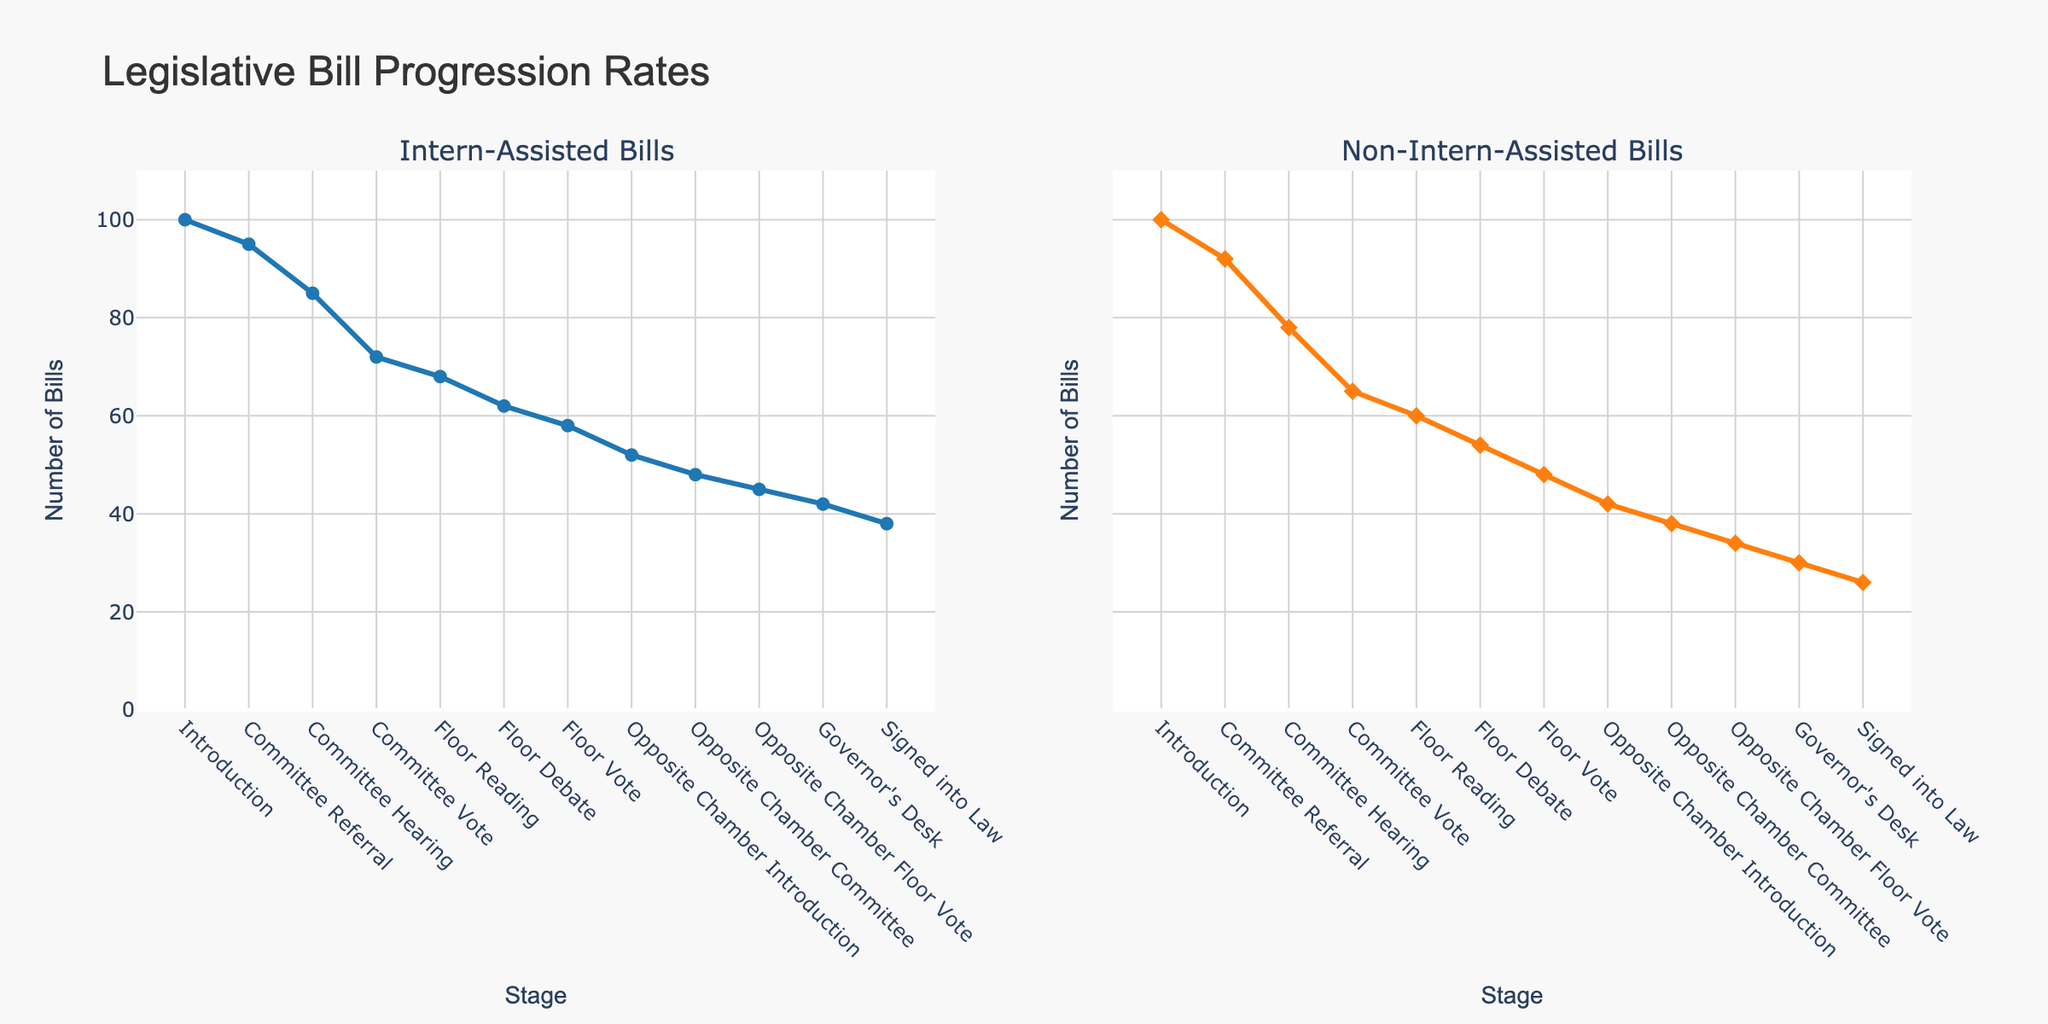What is the title of the figure? The title of the figure is displayed at the top of the plot in a larger font to indicate the main topic being visualized.
Answer: Legislative Bill Progression Rates What is the color of the line representing Intern-Assisted Bills? The color of the line representing Intern-Assisted Bills can be observed by examining the line and its associated data points on the left subplot.
Answer: Blue At which stage do Intern-Assisted Bills and Non-Intern-Assisted Bills diverge the most? To identify the stage where the divergence is greatest, look for the stage where the vertical distance between the two lines in their respective subplots is the largest. This occurs at the Governor's Desk stage.
Answer: Governor's Desk How many bills reach the Floor Reading stage for Intern-Assisted Bills? The number of bills at each stage can be read directly from the y-axis of the left subplot for the Intern-Assisted Bills. At the Floor Reading stage, the y-value is noted.
Answer: 68 Which category has a higher number of bills reaching the Governor's Desk, Intern-Assisted or Non-Intern-Assisted? Compare the y-values for the Governor's Desk stage in both subplots.
Answer: Intern-Assisted What is the overall trend observed for Intern-Assisted Bills as they progress through the stages? Examine the line in the Intern-Assisted Bills subplot to describe the general pattern from Introduction to Signed into Law.
Answer: Generally decreasing In which stages do both Intern-Assisted and Non-Intern-Assisted Bills have the same number of bills? Identify the stages where the y-values in both subplots are equal.
Answer: Introduction 